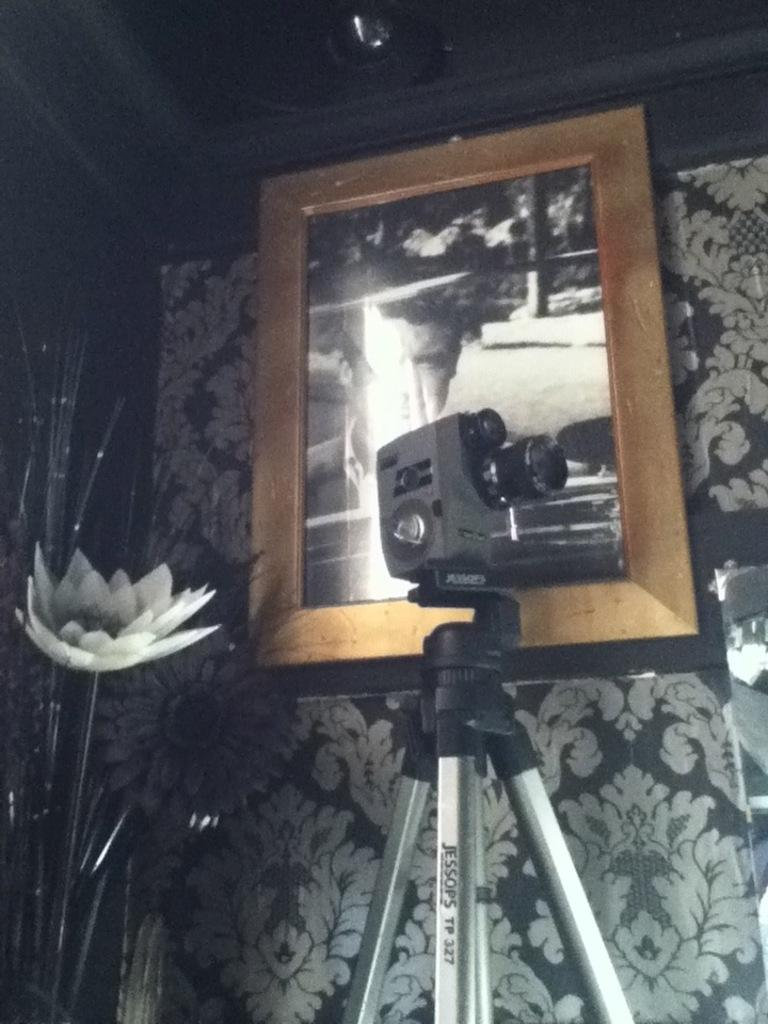What is the main object in the image? There is a camera with a stand in the image. What other objects can be seen in the image? There is a decorative object and a frame on the wall in the image. What type of knowledge can be gained from the coil in the image? There is no coil present in the image, so no knowledge can be gained from it. 